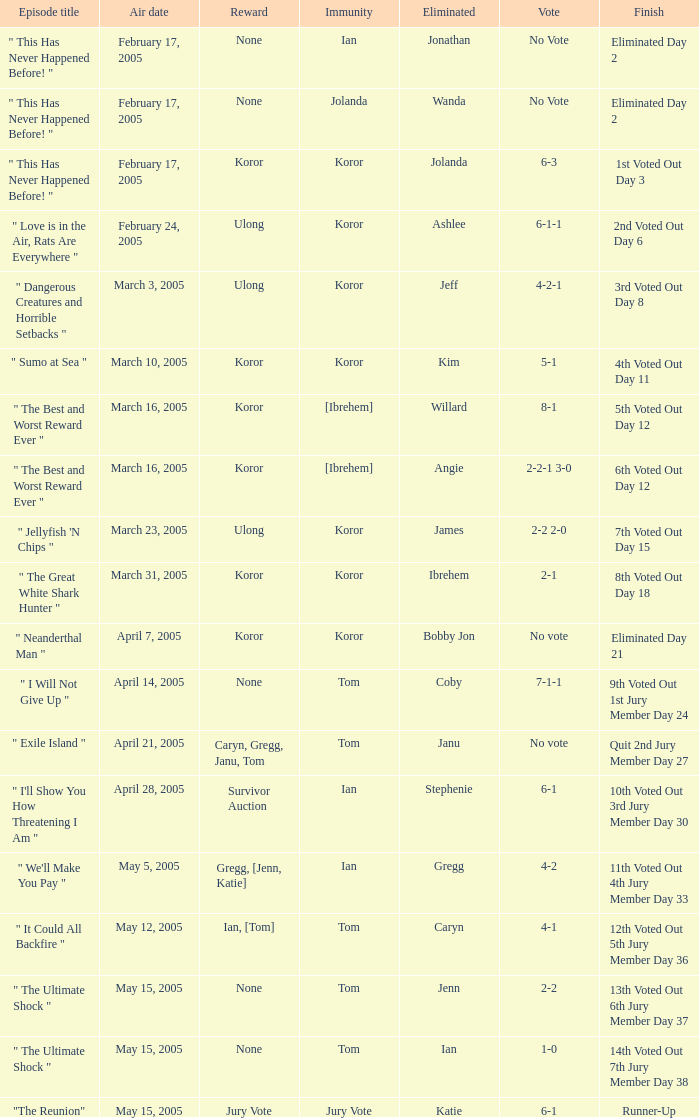What was the number of persons with immunity during the episode of wanda's elimination? 1.0. Can you parse all the data within this table? {'header': ['Episode title', 'Air date', 'Reward', 'Immunity', 'Eliminated', 'Vote', 'Finish'], 'rows': [['" This Has Never Happened Before! "', 'February 17, 2005', 'None', 'Ian', 'Jonathan', 'No Vote', 'Eliminated Day 2'], ['" This Has Never Happened Before! "', 'February 17, 2005', 'None', 'Jolanda', 'Wanda', 'No Vote', 'Eliminated Day 2'], ['" This Has Never Happened Before! "', 'February 17, 2005', 'Koror', 'Koror', 'Jolanda', '6-3', '1st Voted Out Day 3'], ['" Love is in the Air, Rats Are Everywhere "', 'February 24, 2005', 'Ulong', 'Koror', 'Ashlee', '6-1-1', '2nd Voted Out Day 6'], ['" Dangerous Creatures and Horrible Setbacks "', 'March 3, 2005', 'Ulong', 'Koror', 'Jeff', '4-2-1', '3rd Voted Out Day 8'], ['" Sumo at Sea "', 'March 10, 2005', 'Koror', 'Koror', 'Kim', '5-1', '4th Voted Out Day 11'], ['" The Best and Worst Reward Ever "', 'March 16, 2005', 'Koror', '[Ibrehem]', 'Willard', '8-1', '5th Voted Out Day 12'], ['" The Best and Worst Reward Ever "', 'March 16, 2005', 'Koror', '[Ibrehem]', 'Angie', '2-2-1 3-0', '6th Voted Out Day 12'], ['" Jellyfish \'N Chips "', 'March 23, 2005', 'Ulong', 'Koror', 'James', '2-2 2-0', '7th Voted Out Day 15'], ['" The Great White Shark Hunter "', 'March 31, 2005', 'Koror', 'Koror', 'Ibrehem', '2-1', '8th Voted Out Day 18'], ['" Neanderthal Man "', 'April 7, 2005', 'Koror', 'Koror', 'Bobby Jon', 'No vote', 'Eliminated Day 21'], ['" I Will Not Give Up "', 'April 14, 2005', 'None', 'Tom', 'Coby', '7-1-1', '9th Voted Out 1st Jury Member Day 24'], ['" Exile Island "', 'April 21, 2005', 'Caryn, Gregg, Janu, Tom', 'Tom', 'Janu', 'No vote', 'Quit 2nd Jury Member Day 27'], ['" I\'ll Show You How Threatening I Am "', 'April 28, 2005', 'Survivor Auction', 'Ian', 'Stephenie', '6-1', '10th Voted Out 3rd Jury Member Day 30'], ['" We\'ll Make You Pay "', 'May 5, 2005', 'Gregg, [Jenn, Katie]', 'Ian', 'Gregg', '4-2', '11th Voted Out 4th Jury Member Day 33'], ['" It Could All Backfire "', 'May 12, 2005', 'Ian, [Tom]', 'Tom', 'Caryn', '4-1', '12th Voted Out 5th Jury Member Day 36'], ['" The Ultimate Shock "', 'May 15, 2005', 'None', 'Tom', 'Jenn', '2-2', '13th Voted Out 6th Jury Member Day 37'], ['" The Ultimate Shock "', 'May 15, 2005', 'None', 'Tom', 'Ian', '1-0', '14th Voted Out 7th Jury Member Day 38'], ['"The Reunion"', 'May 15, 2005', 'Jury Vote', 'Jury Vote', 'Katie', '6-1', 'Runner-Up']]} 